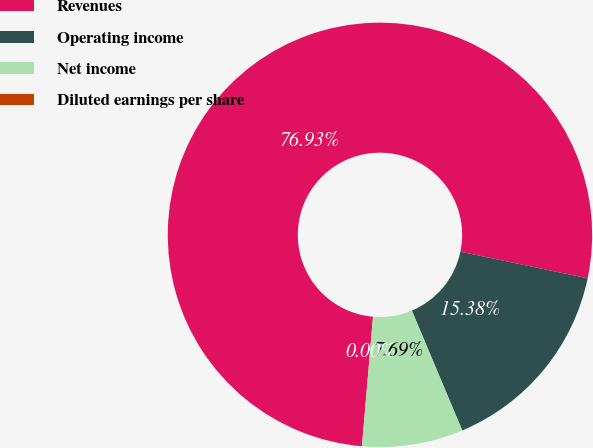Convert chart. <chart><loc_0><loc_0><loc_500><loc_500><pie_chart><fcel>Revenues<fcel>Operating income<fcel>Net income<fcel>Diluted earnings per share<nl><fcel>76.92%<fcel>15.38%<fcel>7.69%<fcel>0.0%<nl></chart> 